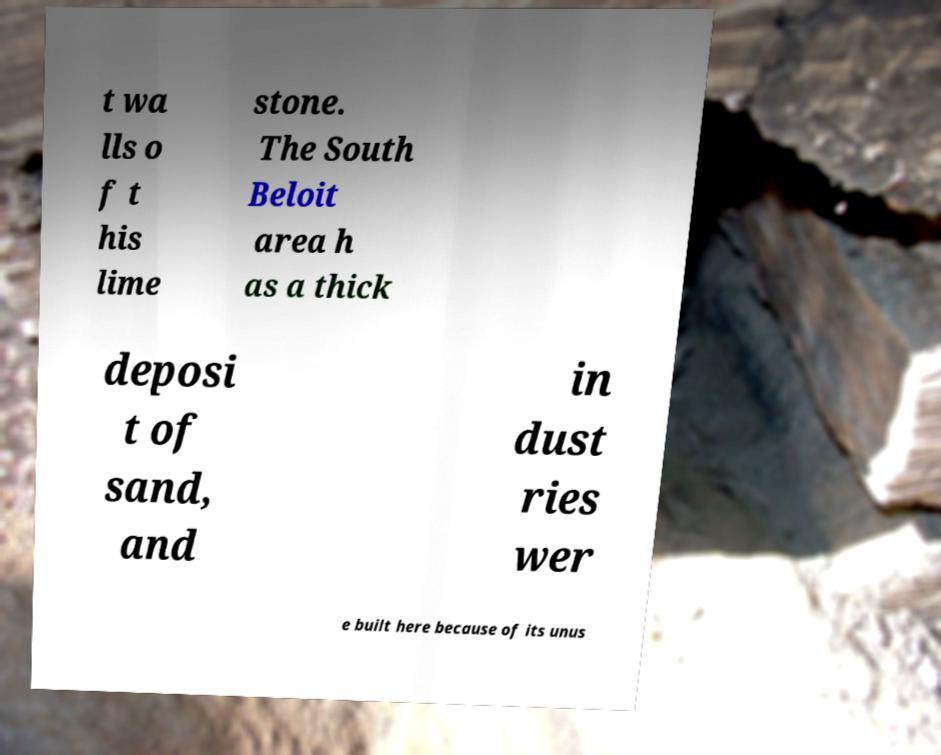Could you extract and type out the text from this image? t wa lls o f t his lime stone. The South Beloit area h as a thick deposi t of sand, and in dust ries wer e built here because of its unus 